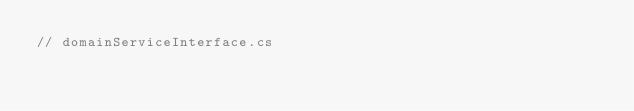Convert code to text. <code><loc_0><loc_0><loc_500><loc_500><_C#_>// domainServiceInterface.cs</code> 